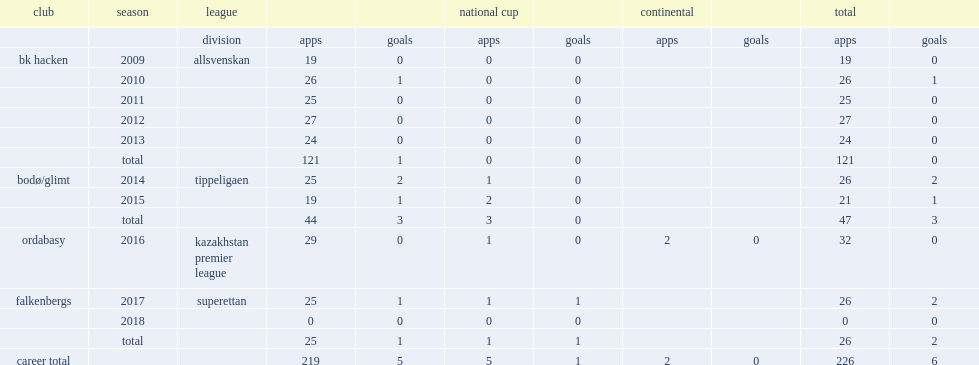In 2016, which league did chatto sign with side ordabasy? Kazakhstan premier league. 